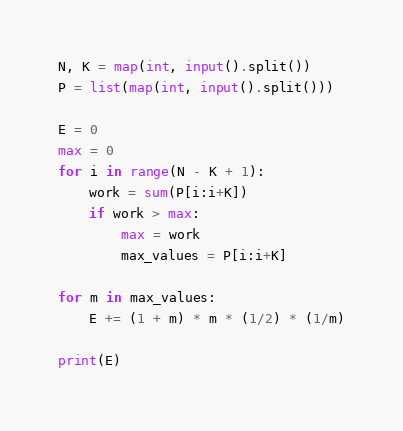<code> <loc_0><loc_0><loc_500><loc_500><_Python_>N, K = map(int, input().split())
P = list(map(int, input().split()))

E = 0
max = 0
for i in range(N - K + 1):
    work = sum(P[i:i+K])
    if work > max:
        max = work
        max_values = P[i:i+K]

for m in max_values:
    E += (1 + m) * m * (1/2) * (1/m)

print(E)

</code> 